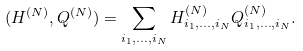<formula> <loc_0><loc_0><loc_500><loc_500>( H ^ { ( N ) } , Q ^ { ( N ) } ) = \sum _ { i _ { 1 } , \dots , i _ { N } } H _ { i _ { 1 } , \dots , i _ { N } } ^ { ( N ) } Q _ { i _ { 1 } , \dots , i _ { N } } ^ { ( N ) } .</formula> 